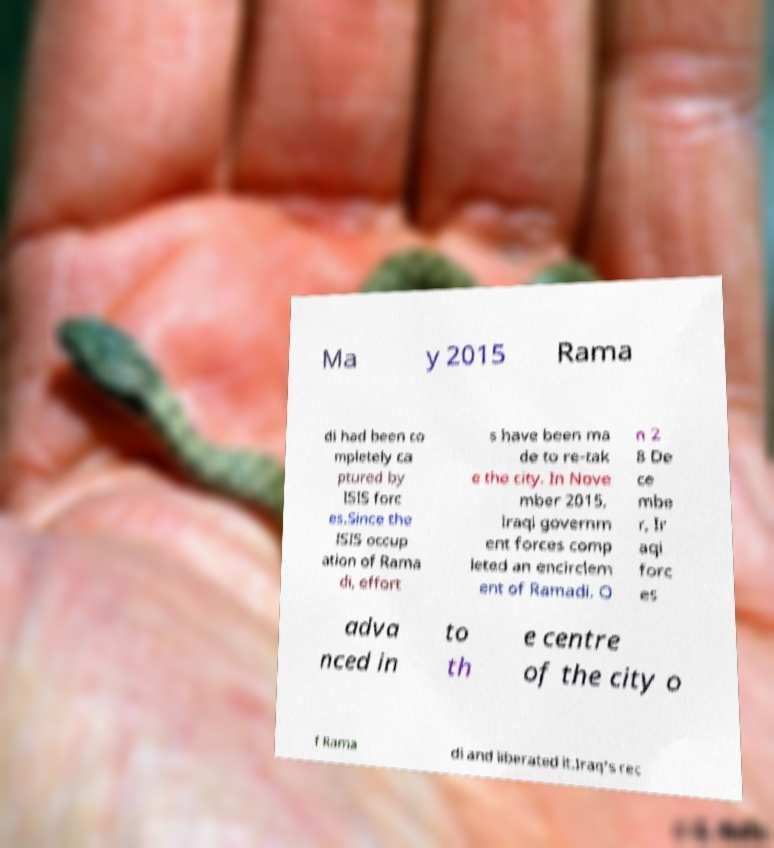For documentation purposes, I need the text within this image transcribed. Could you provide that? Ma y 2015 Rama di had been co mpletely ca ptured by ISIS forc es.Since the ISIS occup ation of Rama di, effort s have been ma de to re-tak e the city. In Nove mber 2015, Iraqi governm ent forces comp leted an encirclem ent of Ramadi. O n 2 8 De ce mbe r, Ir aqi forc es adva nced in to th e centre of the city o f Rama di and liberated it.Iraq's rec 